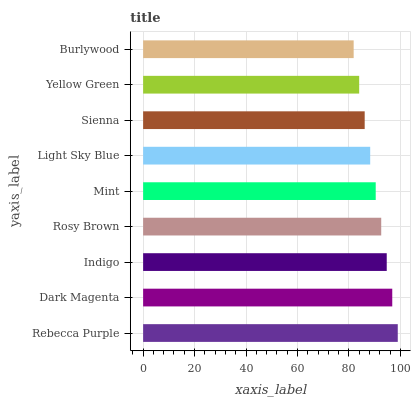Is Burlywood the minimum?
Answer yes or no. Yes. Is Rebecca Purple the maximum?
Answer yes or no. Yes. Is Dark Magenta the minimum?
Answer yes or no. No. Is Dark Magenta the maximum?
Answer yes or no. No. Is Rebecca Purple greater than Dark Magenta?
Answer yes or no. Yes. Is Dark Magenta less than Rebecca Purple?
Answer yes or no. Yes. Is Dark Magenta greater than Rebecca Purple?
Answer yes or no. No. Is Rebecca Purple less than Dark Magenta?
Answer yes or no. No. Is Mint the high median?
Answer yes or no. Yes. Is Mint the low median?
Answer yes or no. Yes. Is Light Sky Blue the high median?
Answer yes or no. No. Is Yellow Green the low median?
Answer yes or no. No. 